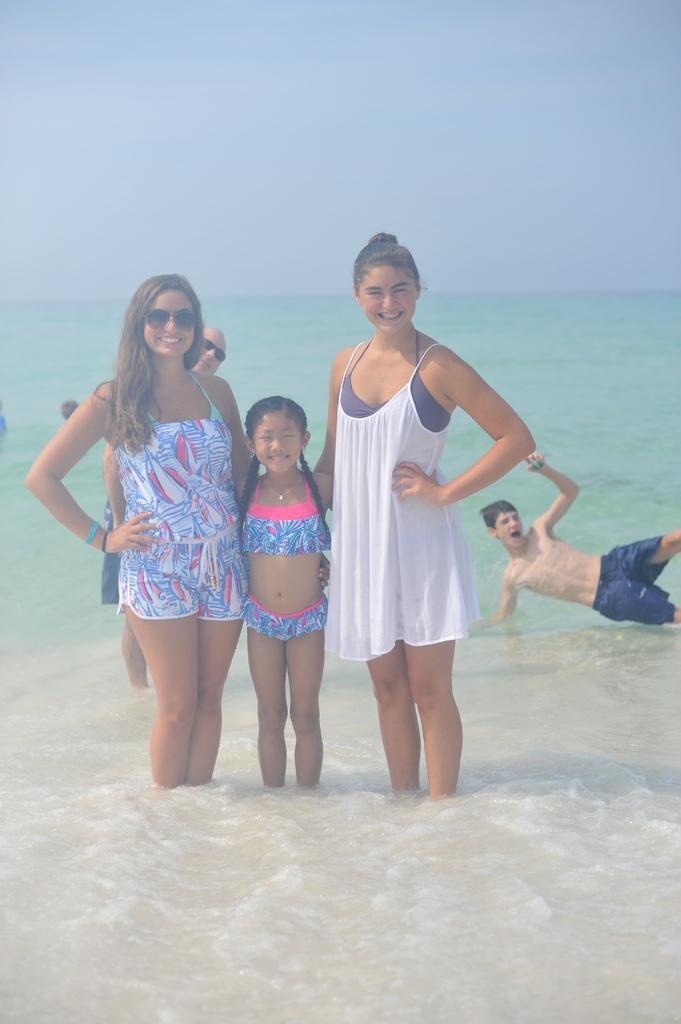In one or two sentences, can you explain what this image depicts? In this image we can see two women and one girl is standing. Right side of the image one boy is there. Background an ocean is present. 